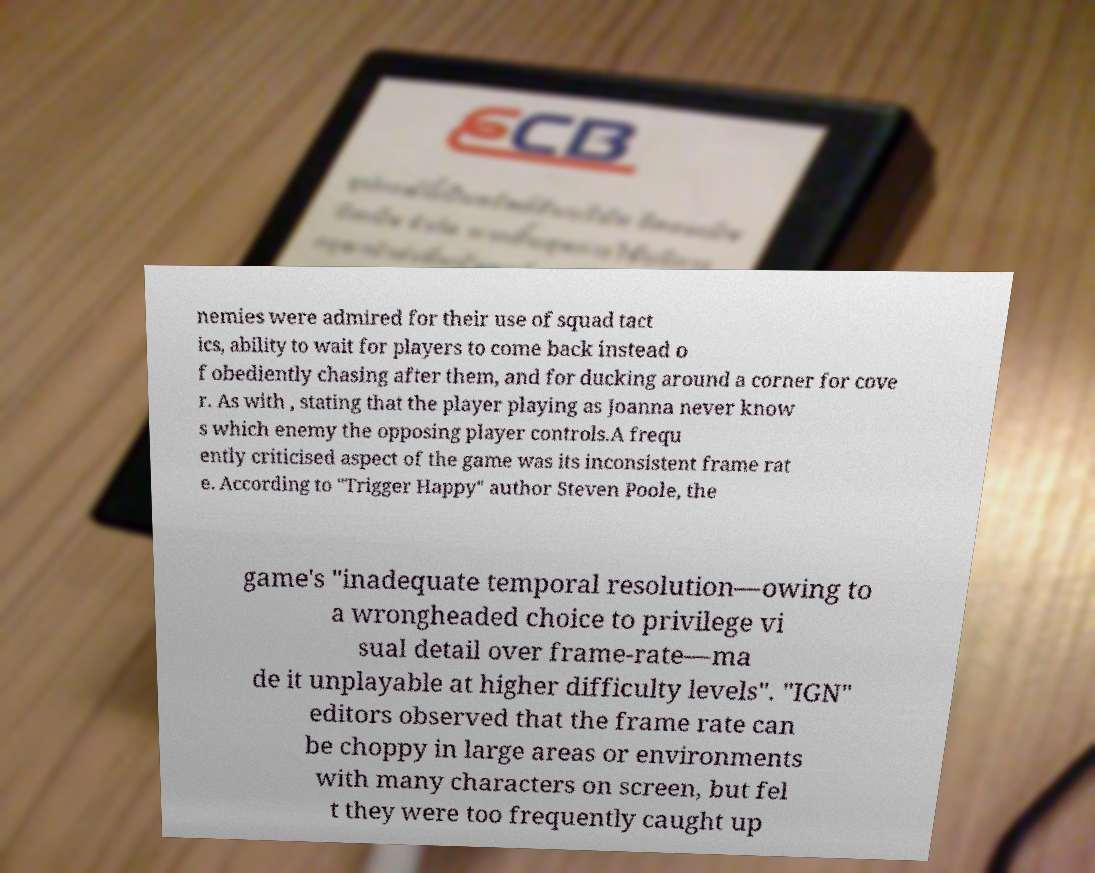I need the written content from this picture converted into text. Can you do that? nemies were admired for their use of squad tact ics, ability to wait for players to come back instead o f obediently chasing after them, and for ducking around a corner for cove r. As with , stating that the player playing as Joanna never know s which enemy the opposing player controls.A frequ ently criticised aspect of the game was its inconsistent frame rat e. According to "Trigger Happy" author Steven Poole, the game's "inadequate temporal resolution—owing to a wrongheaded choice to privilege vi sual detail over frame-rate—ma de it unplayable at higher difficulty levels". "IGN" editors observed that the frame rate can be choppy in large areas or environments with many characters on screen, but fel t they were too frequently caught up 